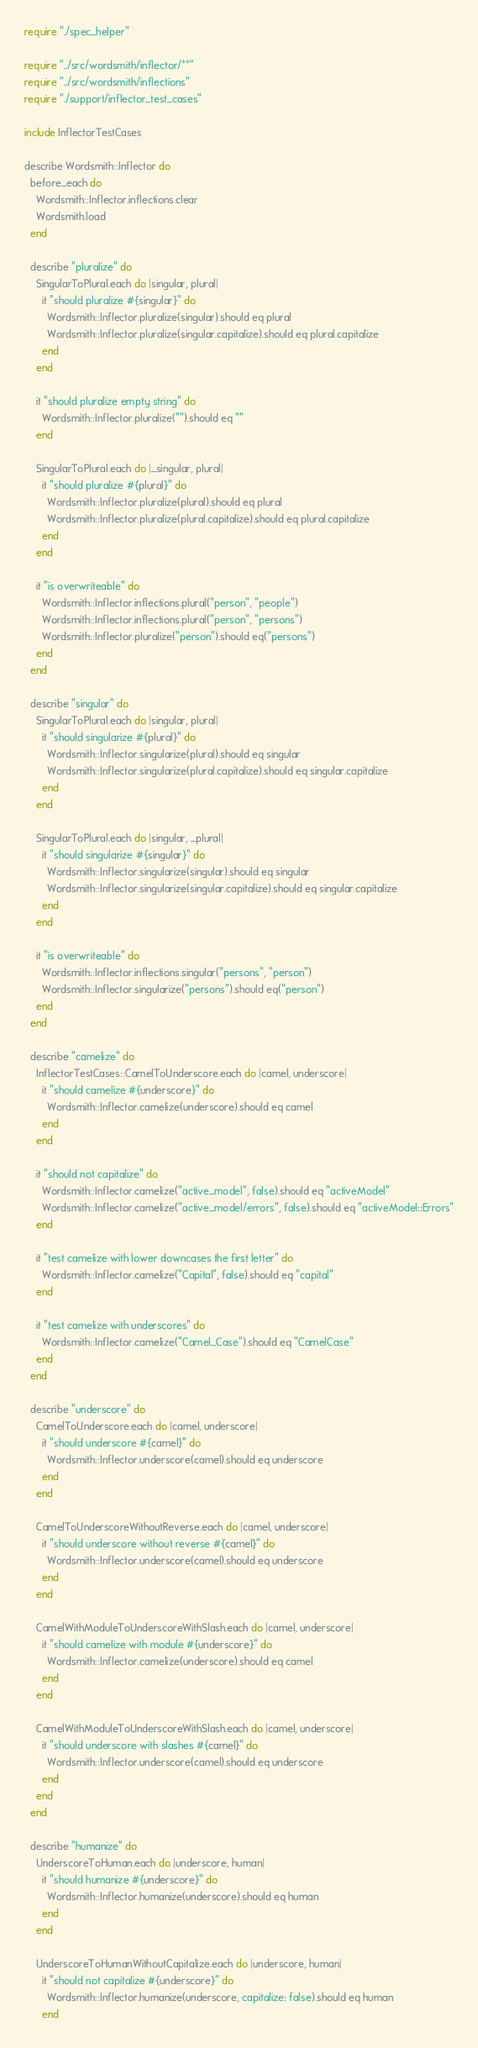Convert code to text. <code><loc_0><loc_0><loc_500><loc_500><_Crystal_>require "./spec_helper"

require "../src/wordsmith/inflector/**"
require "../src/wordsmith/inflections"
require "./support/inflector_test_cases"

include InflectorTestCases

describe Wordsmith::Inflector do
  before_each do
    Wordsmith::Inflector.inflections.clear
    Wordsmith.load
  end

  describe "pluralize" do
    SingularToPlural.each do |singular, plural|
      it "should pluralize #{singular}" do
        Wordsmith::Inflector.pluralize(singular).should eq plural
        Wordsmith::Inflector.pluralize(singular.capitalize).should eq plural.capitalize
      end
    end

    it "should pluralize empty string" do
      Wordsmith::Inflector.pluralize("").should eq ""
    end

    SingularToPlural.each do |_singular, plural|
      it "should pluralize #{plural}" do
        Wordsmith::Inflector.pluralize(plural).should eq plural
        Wordsmith::Inflector.pluralize(plural.capitalize).should eq plural.capitalize
      end
    end

    it "is overwriteable" do
      Wordsmith::Inflector.inflections.plural("person", "people")
      Wordsmith::Inflector.inflections.plural("person", "persons")
      Wordsmith::Inflector.pluralize("person").should eq("persons")
    end
  end

  describe "singular" do
    SingularToPlural.each do |singular, plural|
      it "should singularize #{plural}" do
        Wordsmith::Inflector.singularize(plural).should eq singular
        Wordsmith::Inflector.singularize(plural.capitalize).should eq singular.capitalize
      end
    end

    SingularToPlural.each do |singular, _plural|
      it "should singularize #{singular}" do
        Wordsmith::Inflector.singularize(singular).should eq singular
        Wordsmith::Inflector.singularize(singular.capitalize).should eq singular.capitalize
      end
    end

    it "is overwriteable" do
      Wordsmith::Inflector.inflections.singular("persons", "person")
      Wordsmith::Inflector.singularize("persons").should eq("person")
    end
  end

  describe "camelize" do
    InflectorTestCases::CamelToUnderscore.each do |camel, underscore|
      it "should camelize #{underscore}" do
        Wordsmith::Inflector.camelize(underscore).should eq camel
      end
    end

    it "should not capitalize" do
      Wordsmith::Inflector.camelize("active_model", false).should eq "activeModel"
      Wordsmith::Inflector.camelize("active_model/errors", false).should eq "activeModel::Errors"
    end

    it "test camelize with lower downcases the first letter" do
      Wordsmith::Inflector.camelize("Capital", false).should eq "capital"
    end

    it "test camelize with underscores" do
      Wordsmith::Inflector.camelize("Camel_Case").should eq "CamelCase"
    end
  end

  describe "underscore" do
    CamelToUnderscore.each do |camel, underscore|
      it "should underscore #{camel}" do
        Wordsmith::Inflector.underscore(camel).should eq underscore
      end
    end

    CamelToUnderscoreWithoutReverse.each do |camel, underscore|
      it "should underscore without reverse #{camel}" do
        Wordsmith::Inflector.underscore(camel).should eq underscore
      end
    end

    CamelWithModuleToUnderscoreWithSlash.each do |camel, underscore|
      it "should camelize with module #{underscore}" do
        Wordsmith::Inflector.camelize(underscore).should eq camel
      end
    end

    CamelWithModuleToUnderscoreWithSlash.each do |camel, underscore|
      it "should underscore with slashes #{camel}" do
        Wordsmith::Inflector.underscore(camel).should eq underscore
      end
    end
  end

  describe "humanize" do
    UnderscoreToHuman.each do |underscore, human|
      it "should humanize #{underscore}" do
        Wordsmith::Inflector.humanize(underscore).should eq human
      end
    end

    UnderscoreToHumanWithoutCapitalize.each do |underscore, human|
      it "should not capitalize #{underscore}" do
        Wordsmith::Inflector.humanize(underscore, capitalize: false).should eq human
      end</code> 